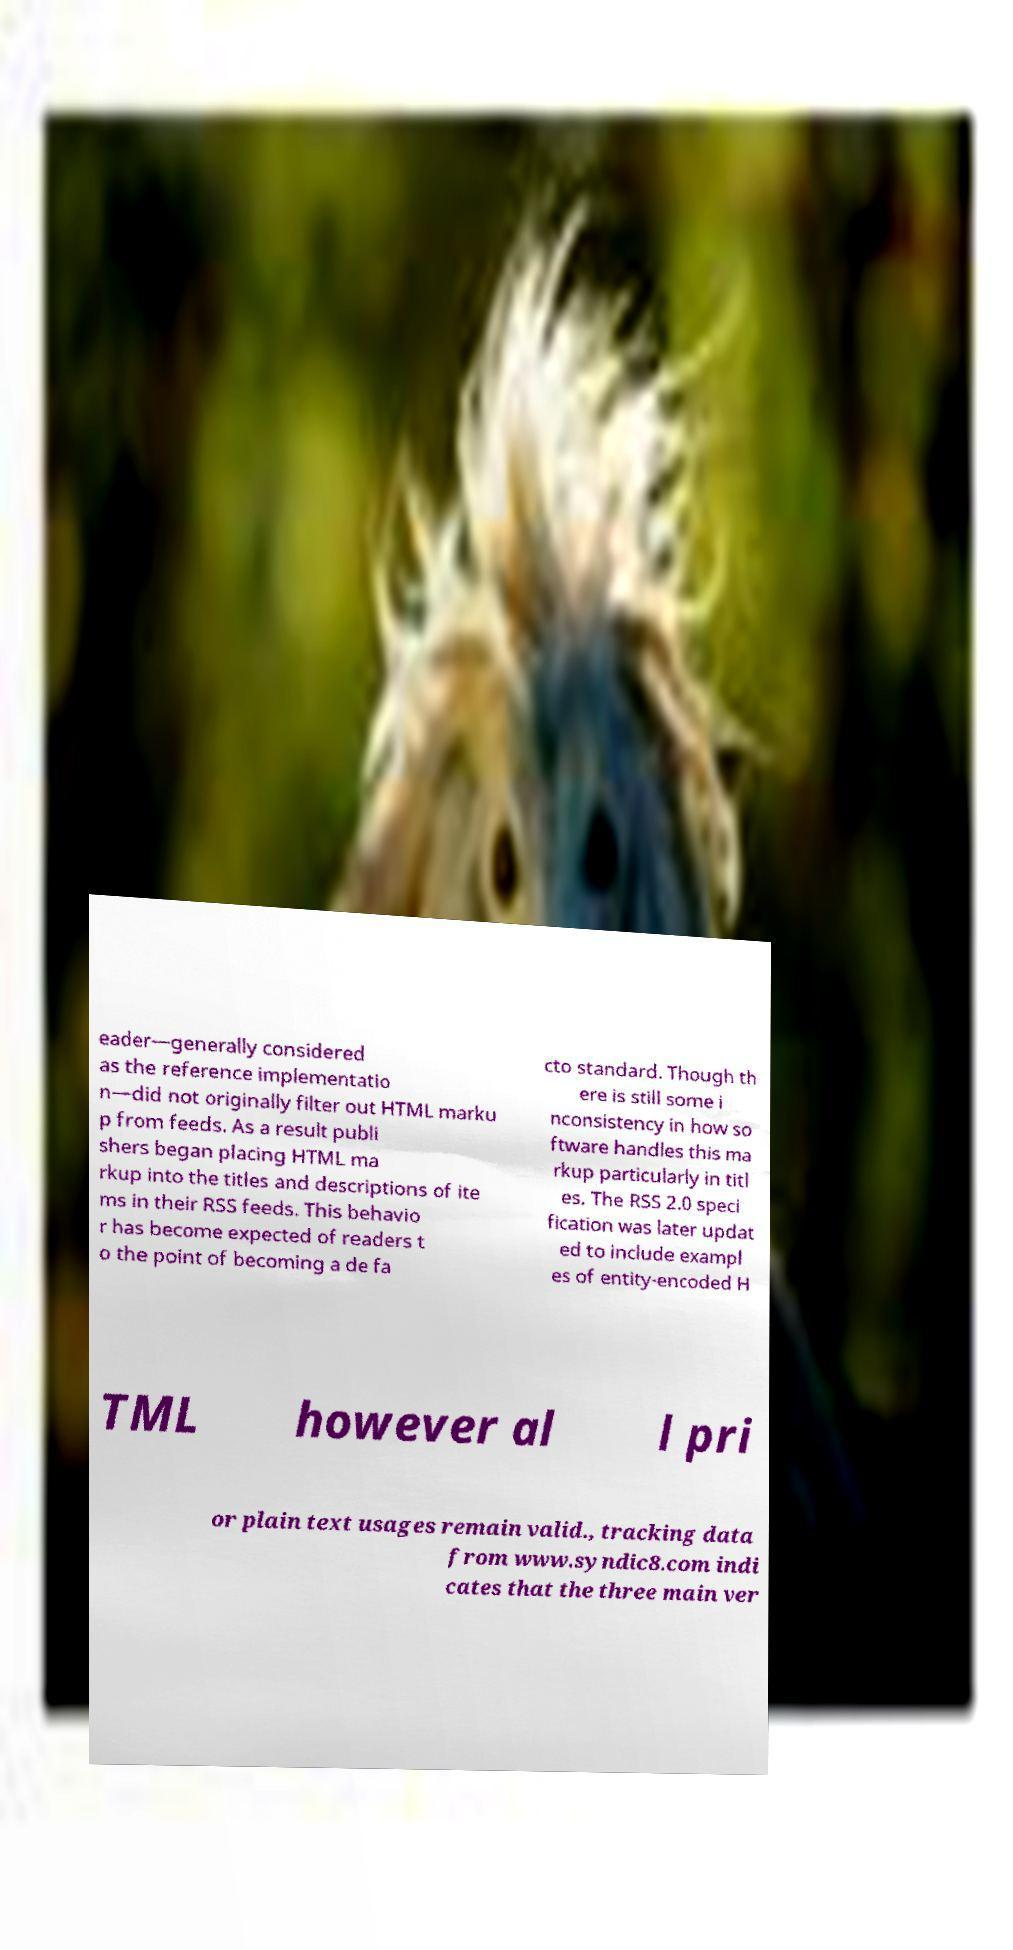Please identify and transcribe the text found in this image. eader—generally considered as the reference implementatio n—did not originally filter out HTML marku p from feeds. As a result publi shers began placing HTML ma rkup into the titles and descriptions of ite ms in their RSS feeds. This behavio r has become expected of readers t o the point of becoming a de fa cto standard. Though th ere is still some i nconsistency in how so ftware handles this ma rkup particularly in titl es. The RSS 2.0 speci fication was later updat ed to include exampl es of entity-encoded H TML however al l pri or plain text usages remain valid., tracking data from www.syndic8.com indi cates that the three main ver 